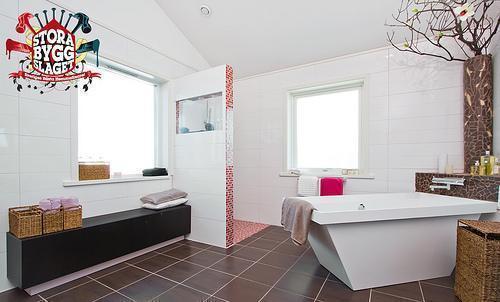How many wicket baskets are on top of the little bench near the doorway?
From the following four choices, select the correct answer to address the question.
Options: Four, three, two, five. Three. 